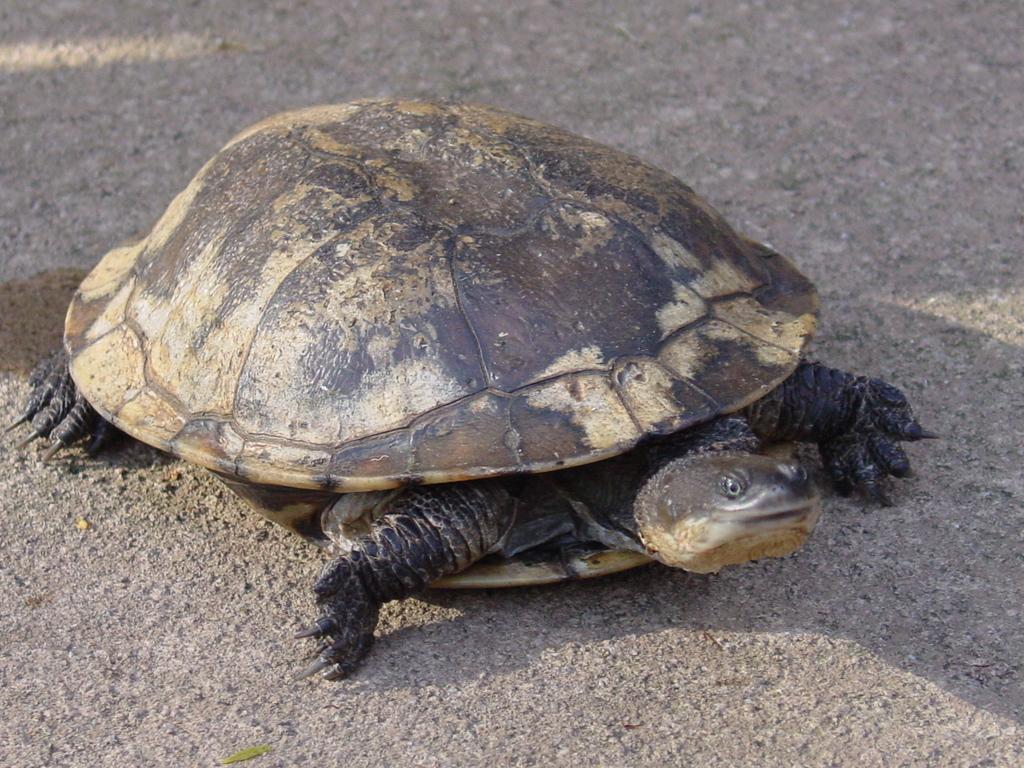Could you give a brief overview of what you see in this image? In this picture we can observe a tortoise on the road. The tortoise is in black and cream color. 